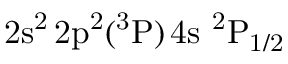Convert formula to latex. <formula><loc_0><loc_0><loc_500><loc_500>2 s ^ { 2 } \, 2 p ^ { 2 } ( ^ { 3 } P ) \, 4 s ^ { 2 } P _ { 1 / 2 }</formula> 